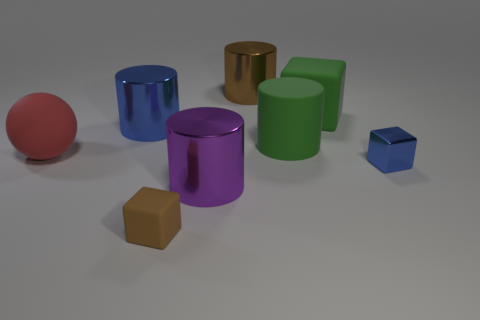How do the lighting and shadows contribute to the image? The lighting in the image creates soft shadows that give a sense of depth and dimension to the objects. The direction of the light appears to be coming from the upper left side, which helps to accentuate the outlines of the shapes and enhances the textures. The interplay of light and shadow adds to the overall aesthetic of the composition. 